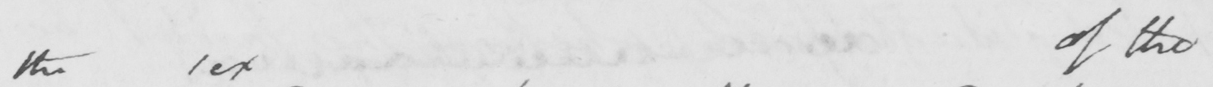Please transcribe the handwritten text in this image. the sex of the 